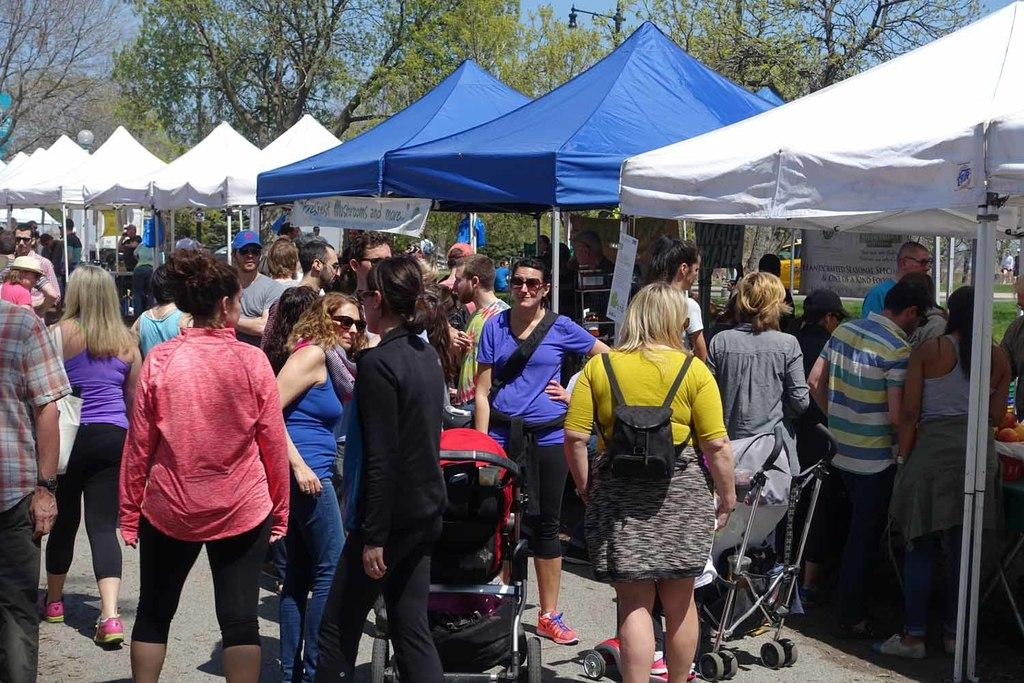What can be seen in the foreground of the picture? There are people and carts in the foreground of the picture. What is located in the center of the picture? There are tents and other objects in the center of the picture. What type of vegetation is visible in the background of the picture? There are trees in the background of the picture. What other object can be seen in the background of the picture? There is a pole in the background of the picture. Can you tell me how much sugar is in the note that is visible in the image? There is no note present in the image, and therefore no sugar content can be determined. What type of railway is depicted in the image? There is no railway present in the image. 